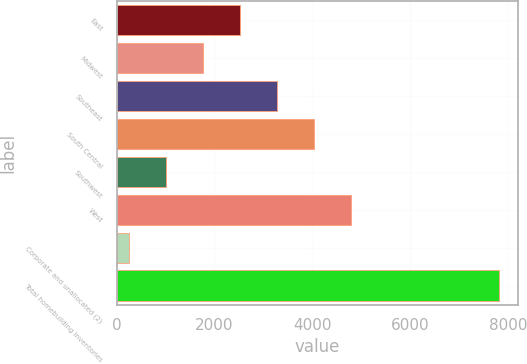Convert chart to OTSL. <chart><loc_0><loc_0><loc_500><loc_500><bar_chart><fcel>East<fcel>Midwest<fcel>Southeast<fcel>South Central<fcel>Southwest<fcel>West<fcel>Corporate and unallocated (2)<fcel>Total homebuilding inventories<nl><fcel>2518.36<fcel>1762.84<fcel>3273.88<fcel>4029.4<fcel>1007.32<fcel>4784.92<fcel>251.8<fcel>7807<nl></chart> 